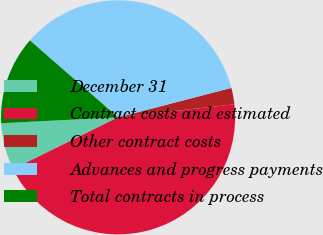Convert chart to OTSL. <chart><loc_0><loc_0><loc_500><loc_500><pie_chart><fcel>December 31<fcel>Contract costs and estimated<fcel>Other contract costs<fcel>Advances and progress payments<fcel>Total contracts in process<nl><fcel>6.49%<fcel>44.49%<fcel>2.27%<fcel>34.53%<fcel>12.22%<nl></chart> 